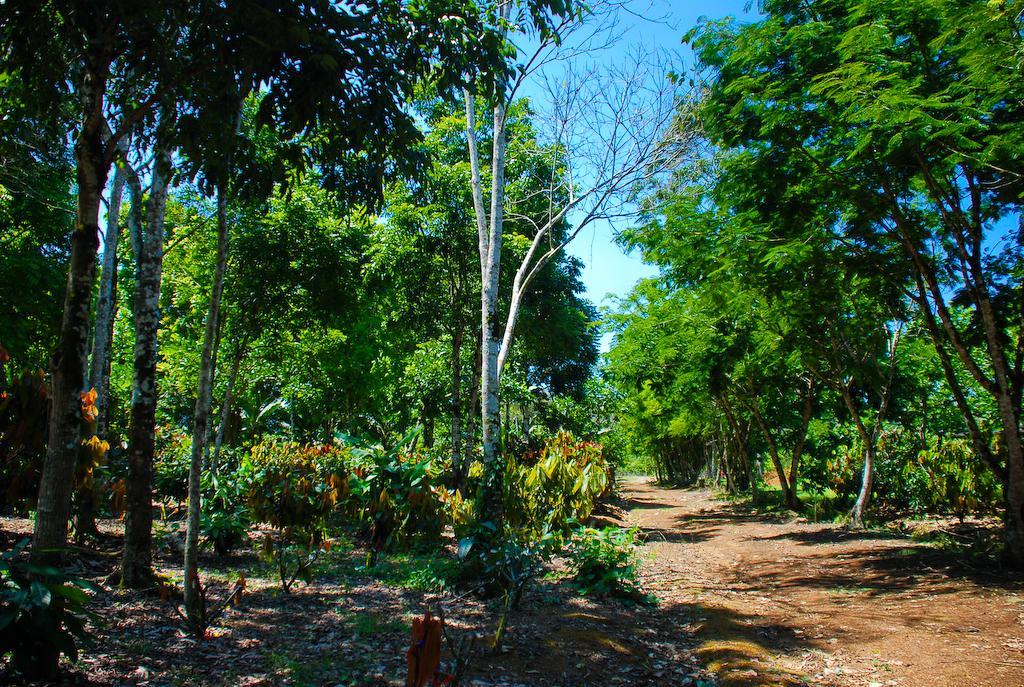Describe this image in one or two sentences. In this picture there are trees in the image and there is path at the bottom side of the image. 